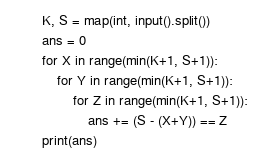<code> <loc_0><loc_0><loc_500><loc_500><_Python_>K, S = map(int, input().split())
ans = 0
for X in range(min(K+1, S+1)):
    for Y in range(min(K+1, S+1)):
        for Z in range(min(K+1, S+1)):
            ans += (S - (X+Y)) == Z
print(ans)
</code> 